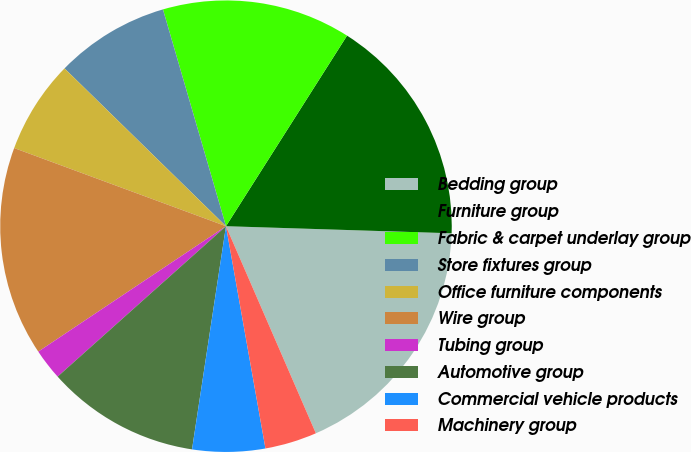Convert chart. <chart><loc_0><loc_0><loc_500><loc_500><pie_chart><fcel>Bedding group<fcel>Furniture group<fcel>Fabric & carpet underlay group<fcel>Store fixtures group<fcel>Office furniture components<fcel>Wire group<fcel>Tubing group<fcel>Automotive group<fcel>Commercial vehicle products<fcel>Machinery group<nl><fcel>17.98%<fcel>16.49%<fcel>13.51%<fcel>8.18%<fcel>6.69%<fcel>15.0%<fcel>2.23%<fcel>10.99%<fcel>5.2%<fcel>3.72%<nl></chart> 